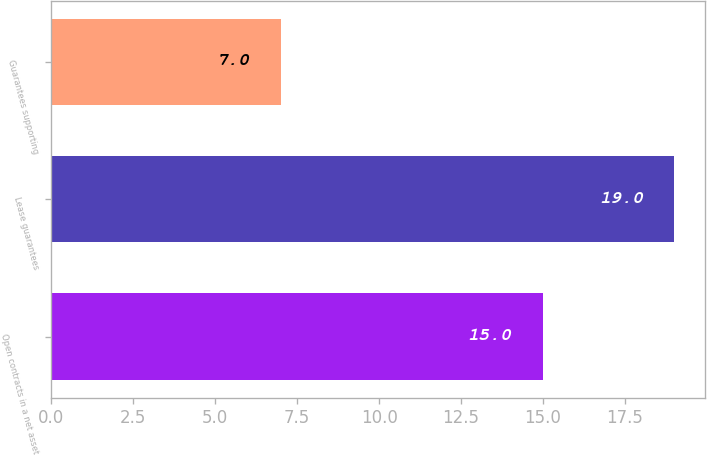<chart> <loc_0><loc_0><loc_500><loc_500><bar_chart><fcel>Open contracts in a net asset<fcel>Lease guarantees<fcel>Guarantees supporting<nl><fcel>15<fcel>19<fcel>7<nl></chart> 